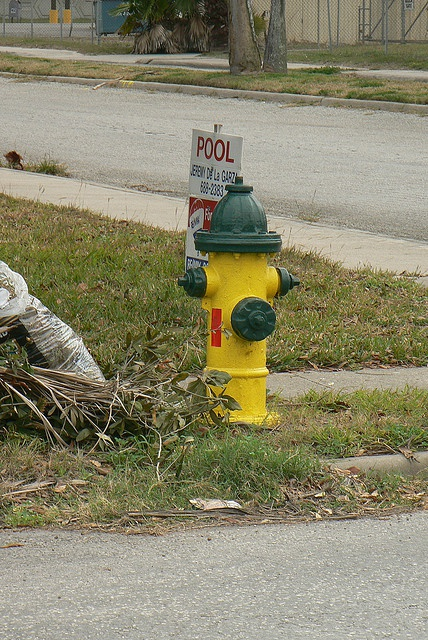Describe the objects in this image and their specific colors. I can see a fire hydrant in gray, black, gold, and olive tones in this image. 